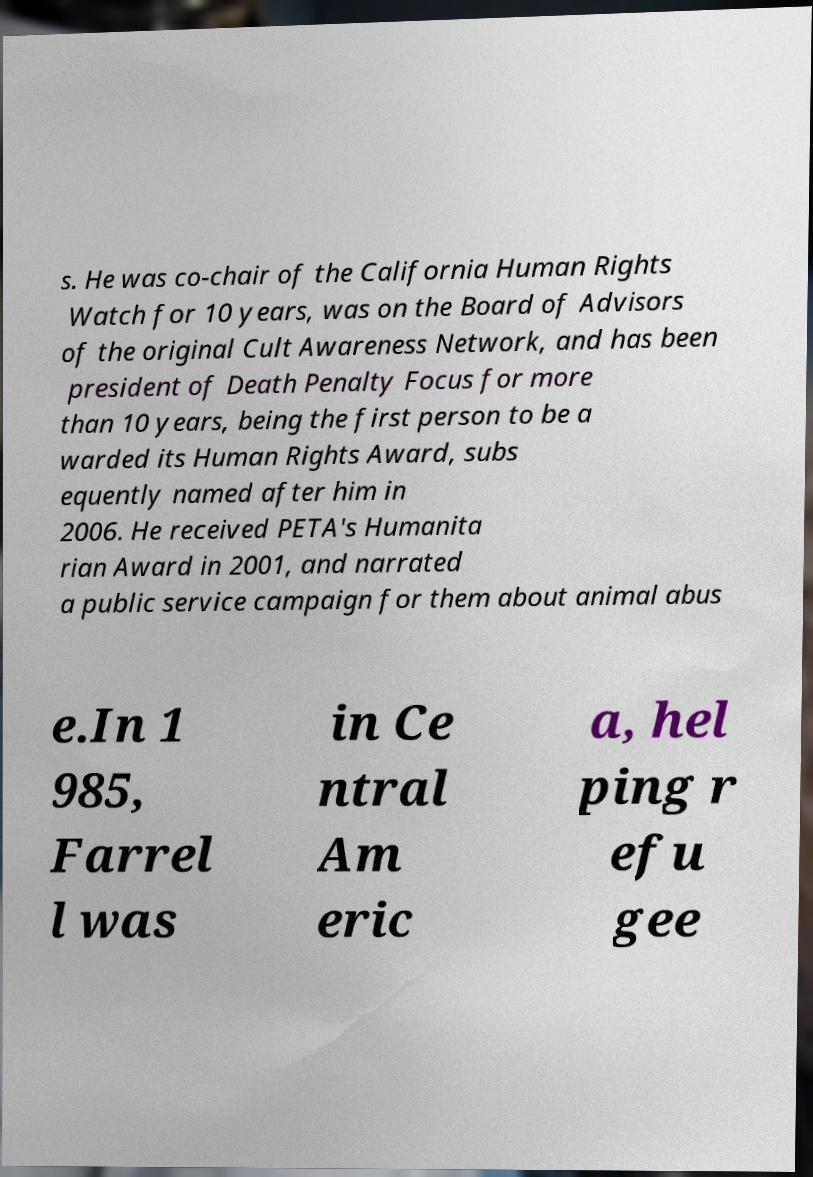Could you extract and type out the text from this image? s. He was co-chair of the California Human Rights Watch for 10 years, was on the Board of Advisors of the original Cult Awareness Network, and has been president of Death Penalty Focus for more than 10 years, being the first person to be a warded its Human Rights Award, subs equently named after him in 2006. He received PETA's Humanita rian Award in 2001, and narrated a public service campaign for them about animal abus e.In 1 985, Farrel l was in Ce ntral Am eric a, hel ping r efu gee 